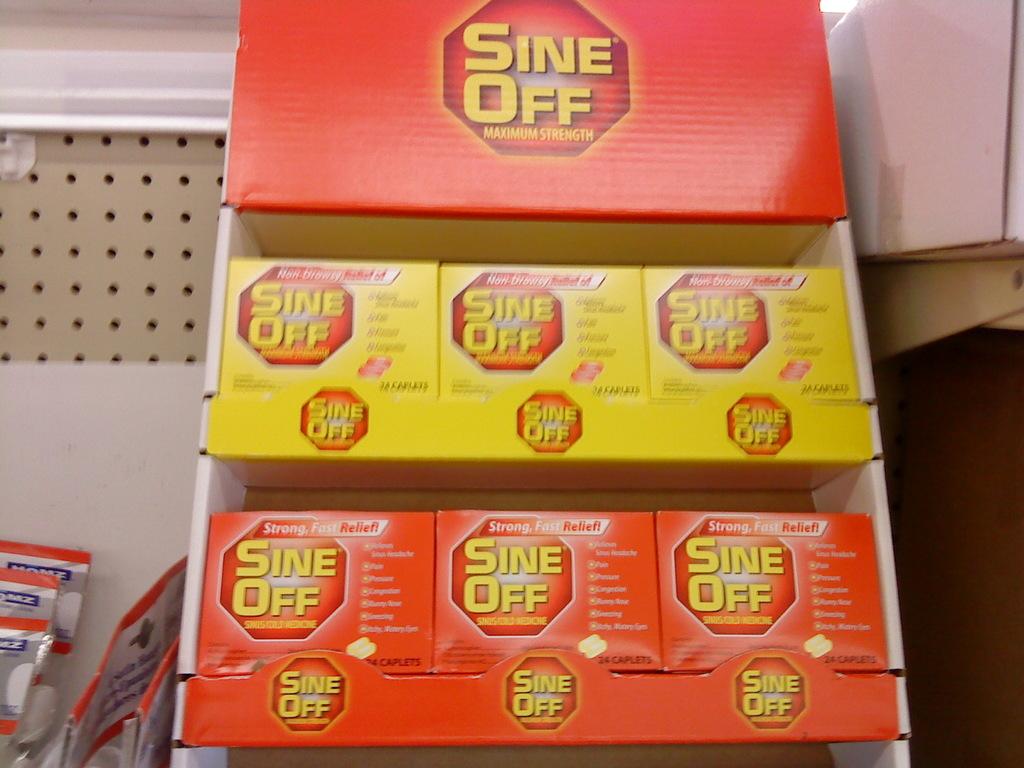What is being advertised here?
Offer a very short reply. Sine off. What's the brand name?
Give a very brief answer. Sine off. 